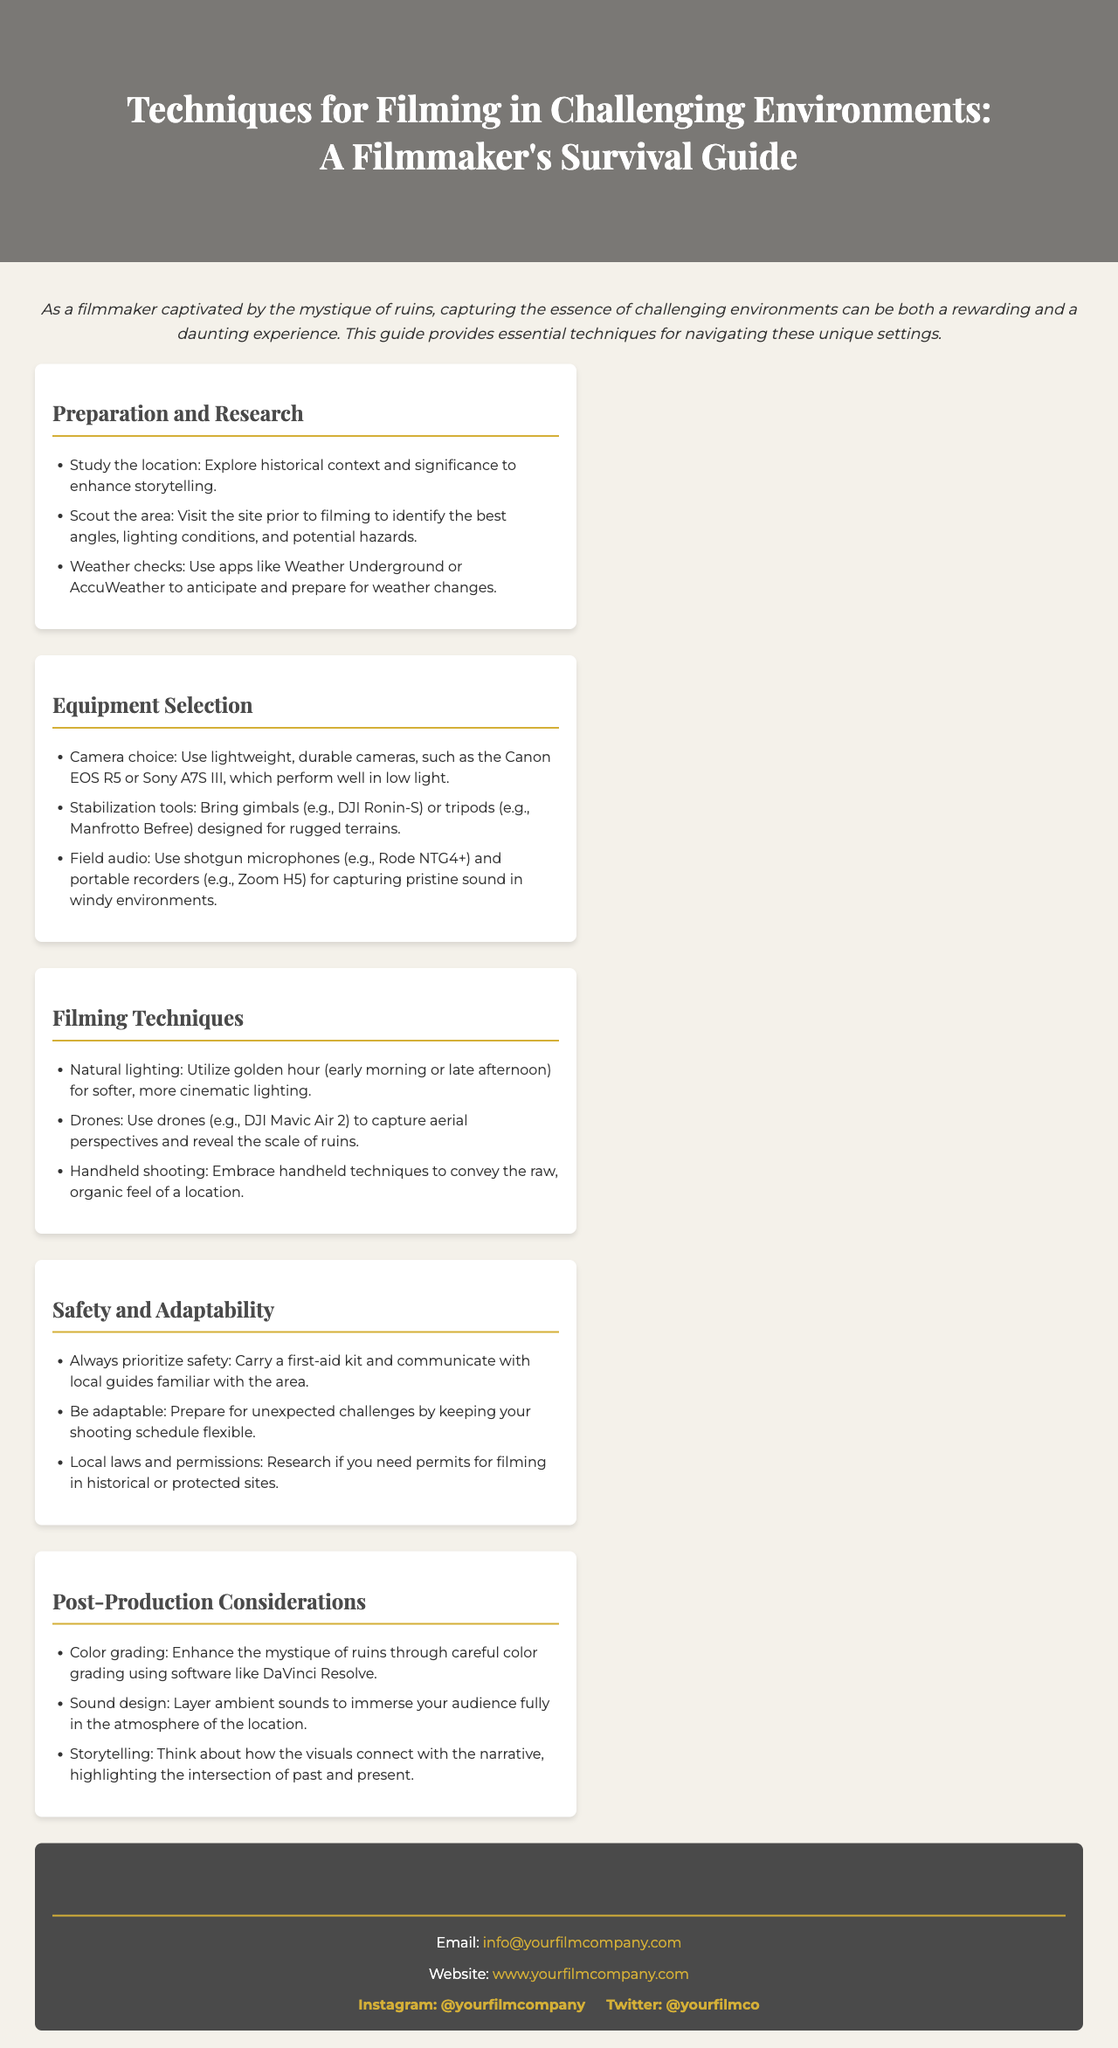what is the title of the guide? The title of the guide is prominently displayed in the header of the document.
Answer: Techniques for Filming in Challenging Environments: A Filmmaker's Survival Guide how many sections are in the content? The content consists of five distinct sections, each providing different aspects of filming techniques.
Answer: Five what is the recommended camera for low light? The guide specifies that certain cameras perform well in low light, providing specific examples.
Answer: Canon EOS R5 or Sony A7S III what is one crucial preparation step before filming? The document outlines important steps to take before filming, focusing on how to enhance storytelling.
Answer: Study the location which time of day is best for natural lighting? The guide emphasizes specific times when lighting conditions are ideal for filming.
Answer: Golden hour what audio equipment is suggested for windy environments? The document advises on specific audio equipment suitable for challenging weather conditions.
Answer: Shotgun microphones and portable recorders what software is recommended for color grading? The guide provides a specific software suggestion for post-production tasks related to visual enhancement.
Answer: DaVinci Resolve what should filmmakers prioritize for safety? The document highlights an important aspect of safety that filmmakers should always keep in mind.
Answer: Always prioritize safety how should filmmakers adapt to unexpected challenges? The document suggests a method for handling unpredictable events during filming.
Answer: Keeping the shooting schedule flexible 